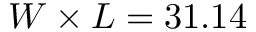<formula> <loc_0><loc_0><loc_500><loc_500>W \times L = 3 1 . 1 4</formula> 